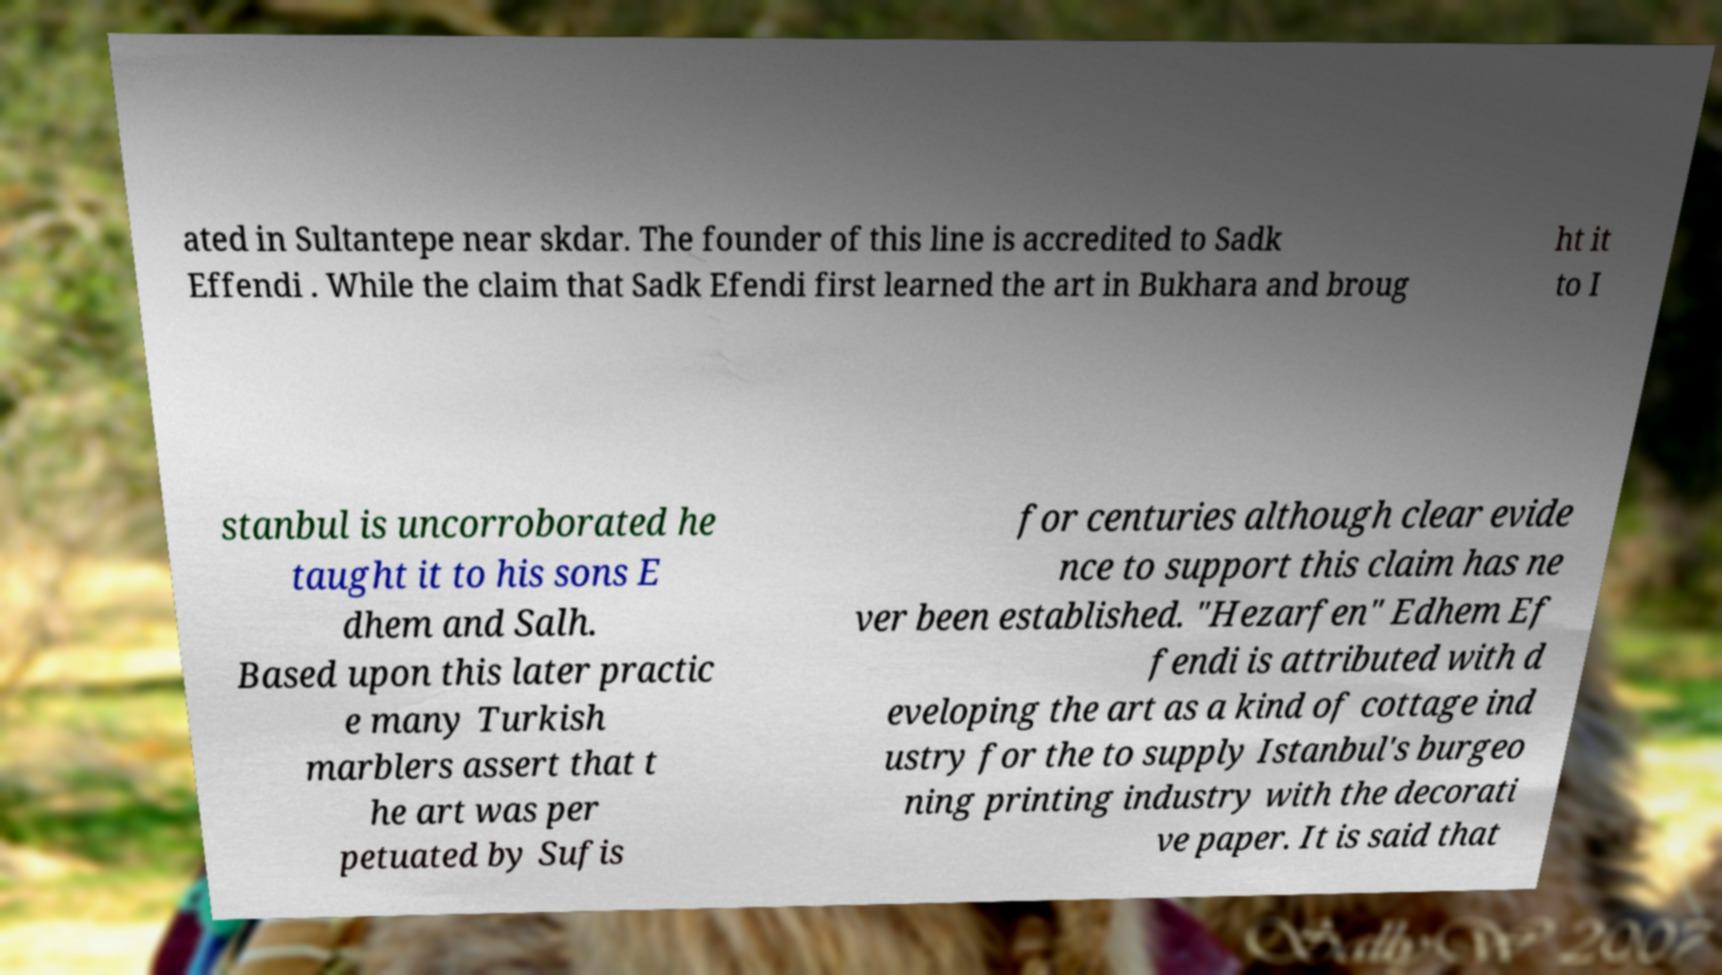For documentation purposes, I need the text within this image transcribed. Could you provide that? ated in Sultantepe near skdar. The founder of this line is accredited to Sadk Effendi . While the claim that Sadk Efendi first learned the art in Bukhara and broug ht it to I stanbul is uncorroborated he taught it to his sons E dhem and Salh. Based upon this later practic e many Turkish marblers assert that t he art was per petuated by Sufis for centuries although clear evide nce to support this claim has ne ver been established. "Hezarfen" Edhem Ef fendi is attributed with d eveloping the art as a kind of cottage ind ustry for the to supply Istanbul's burgeo ning printing industry with the decorati ve paper. It is said that 